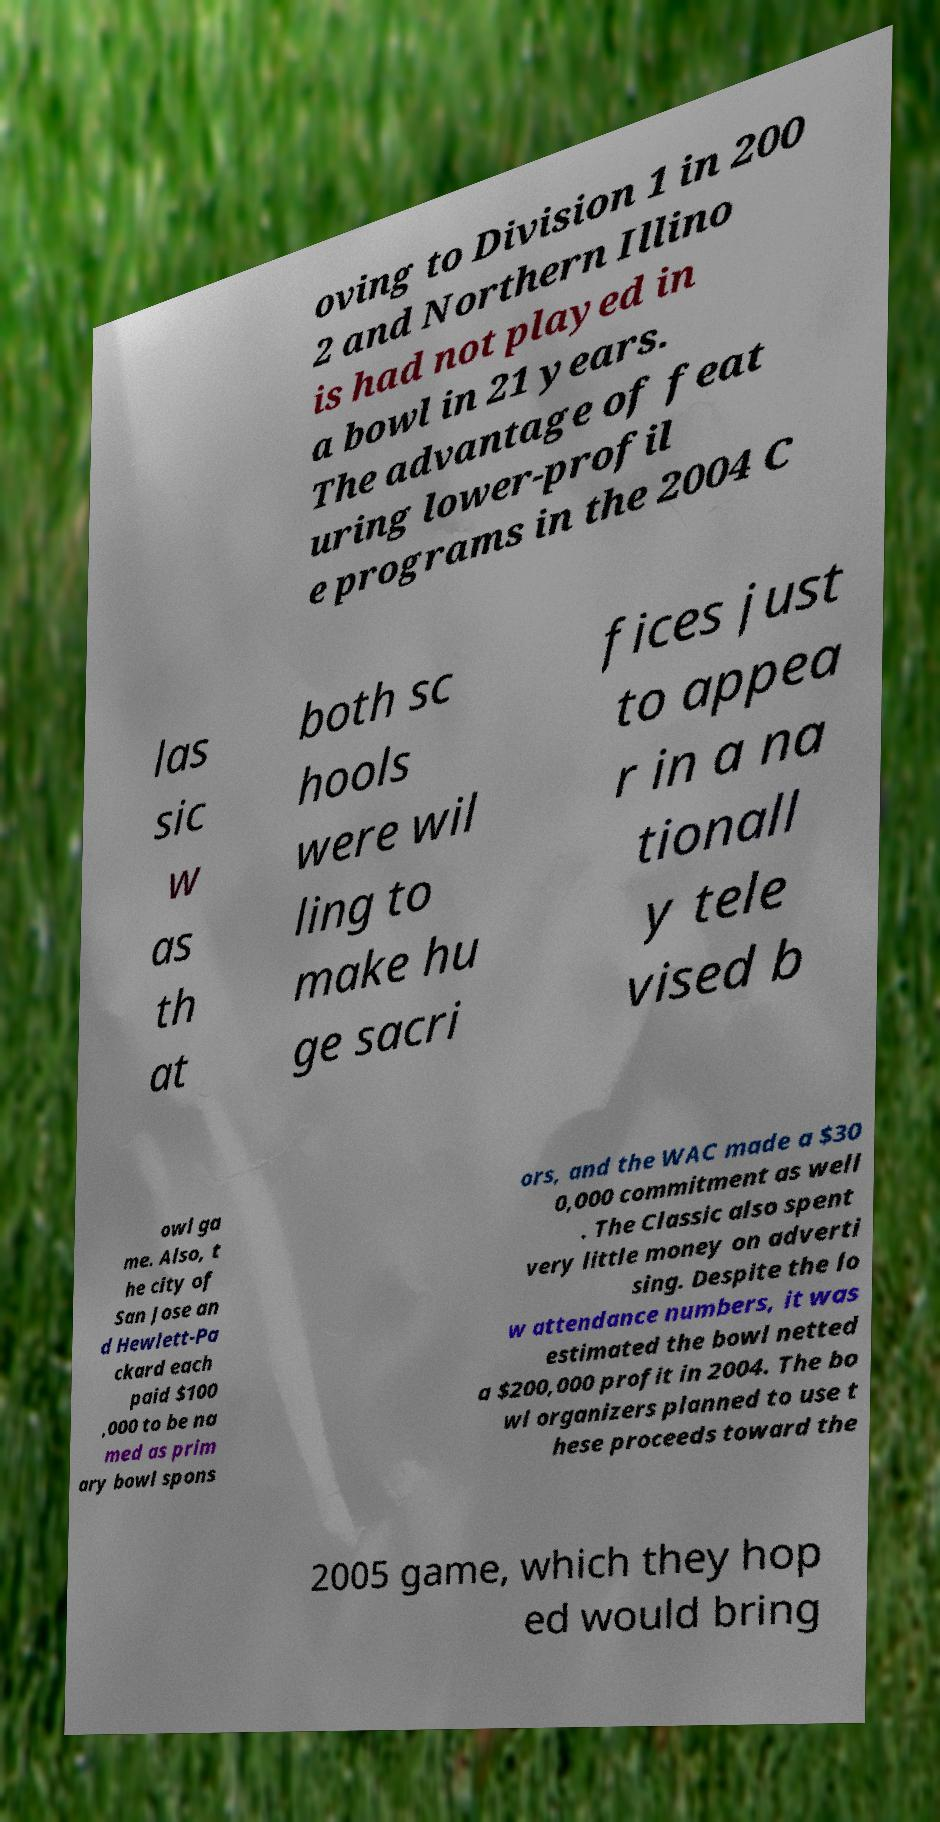Can you accurately transcribe the text from the provided image for me? oving to Division 1 in 200 2 and Northern Illino is had not played in a bowl in 21 years. The advantage of feat uring lower-profil e programs in the 2004 C las sic w as th at both sc hools were wil ling to make hu ge sacri fices just to appea r in a na tionall y tele vised b owl ga me. Also, t he city of San Jose an d Hewlett-Pa ckard each paid $100 ,000 to be na med as prim ary bowl spons ors, and the WAC made a $30 0,000 commitment as well . The Classic also spent very little money on adverti sing. Despite the lo w attendance numbers, it was estimated the bowl netted a $200,000 profit in 2004. The bo wl organizers planned to use t hese proceeds toward the 2005 game, which they hop ed would bring 